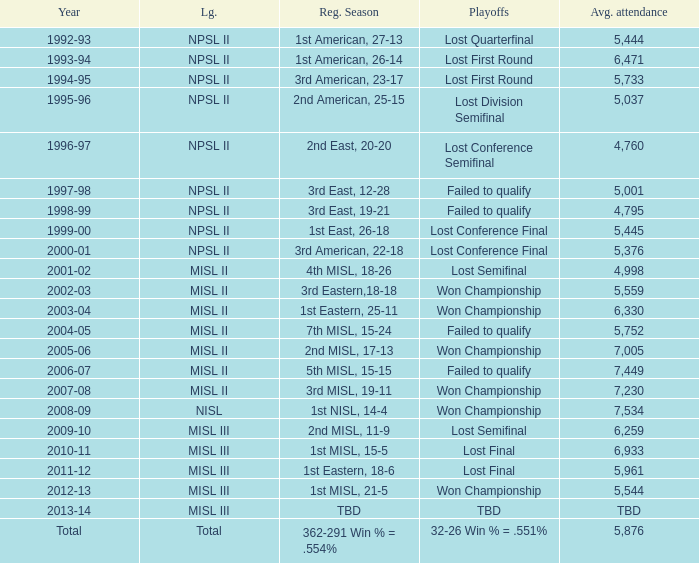In 2010-11, what was the League name? MISL III. 